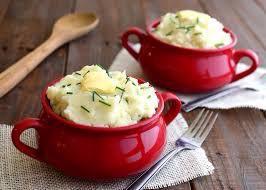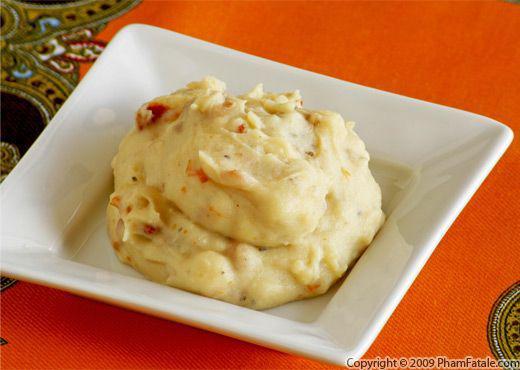The first image is the image on the left, the second image is the image on the right. Considering the images on both sides, is "An image shows a red container with a fork next to it." valid? Answer yes or no. Yes. The first image is the image on the left, the second image is the image on the right. For the images displayed, is the sentence "In one image, mashed potatoes are served in a red bowl with a pat of butter and chopped chives." factually correct? Answer yes or no. Yes. 